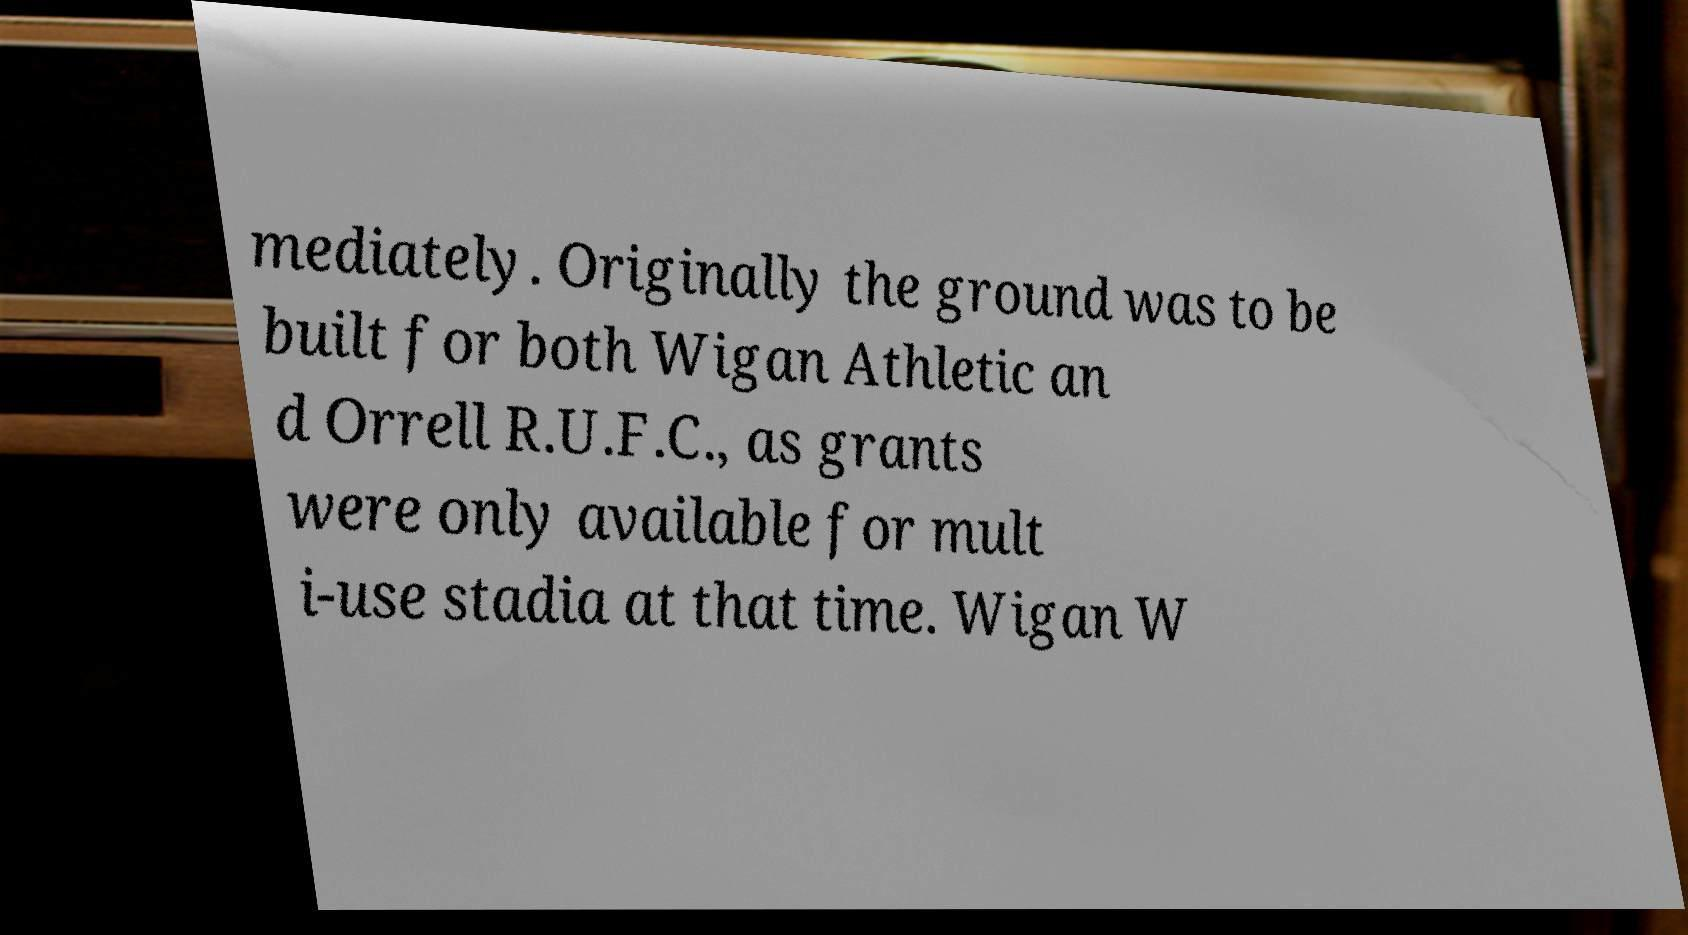Please read and relay the text visible in this image. What does it say? mediately. Originally the ground was to be built for both Wigan Athletic an d Orrell R.U.F.C., as grants were only available for mult i-use stadia at that time. Wigan W 